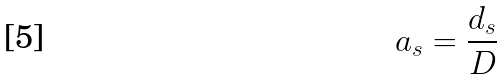<formula> <loc_0><loc_0><loc_500><loc_500>a _ { s } = \frac { d _ { s } } { D }</formula> 